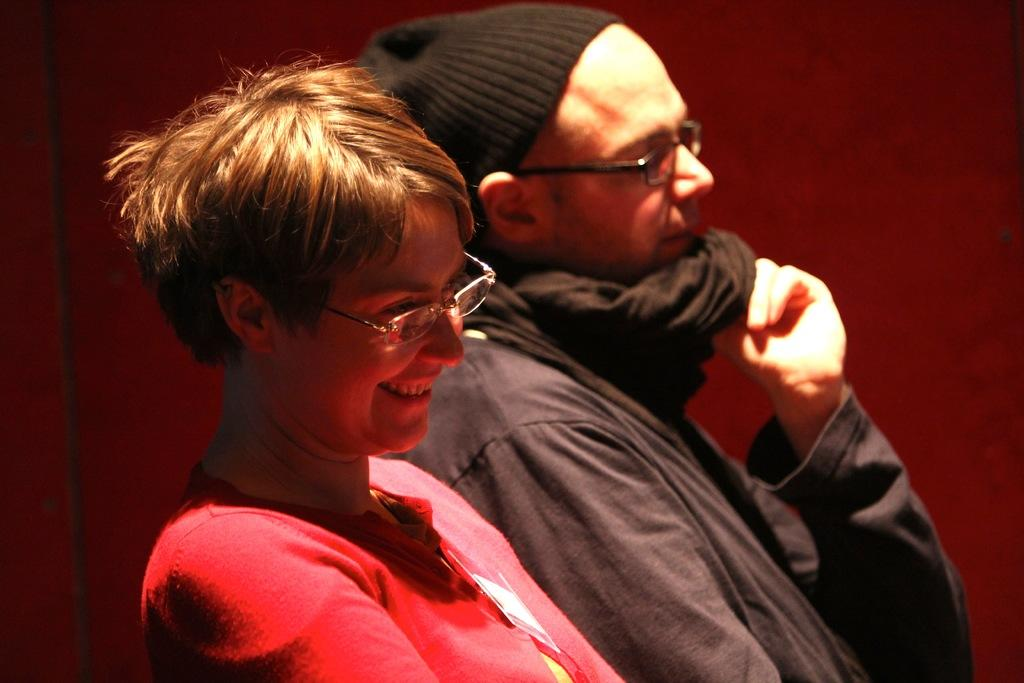How many people are in the image? There are two persons in the image. What is the woman wearing in the image? The woman is wearing a red t-shirt and spectacles. What can be seen on the head of the other person in the image? The other person is wearing a cap. What does the grandmother regret in the image? There is no grandmother present in the image, and therefore no regret can be observed. Can you see any deer in the image? There are no deer present in the image. 